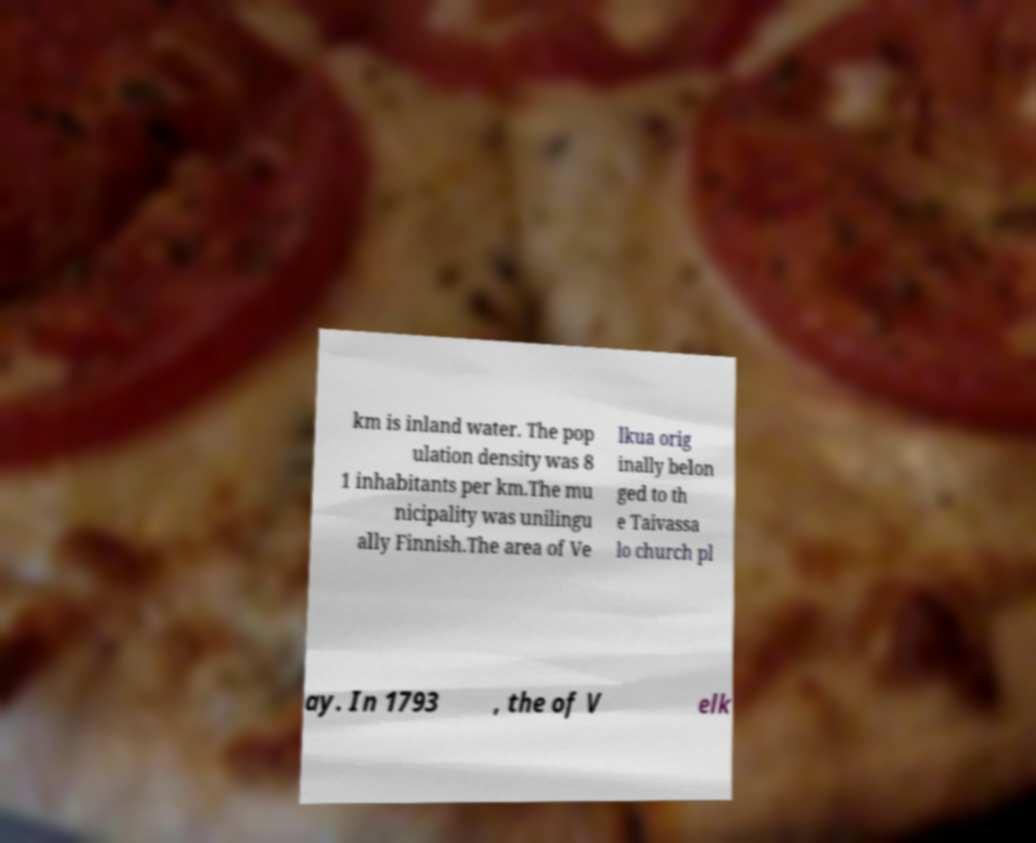Please identify and transcribe the text found in this image. km is inland water. The pop ulation density was 8 1 inhabitants per km.The mu nicipality was unilingu ally Finnish.The area of Ve lkua orig inally belon ged to th e Taivassa lo church pl ay. In 1793 , the of V elk 